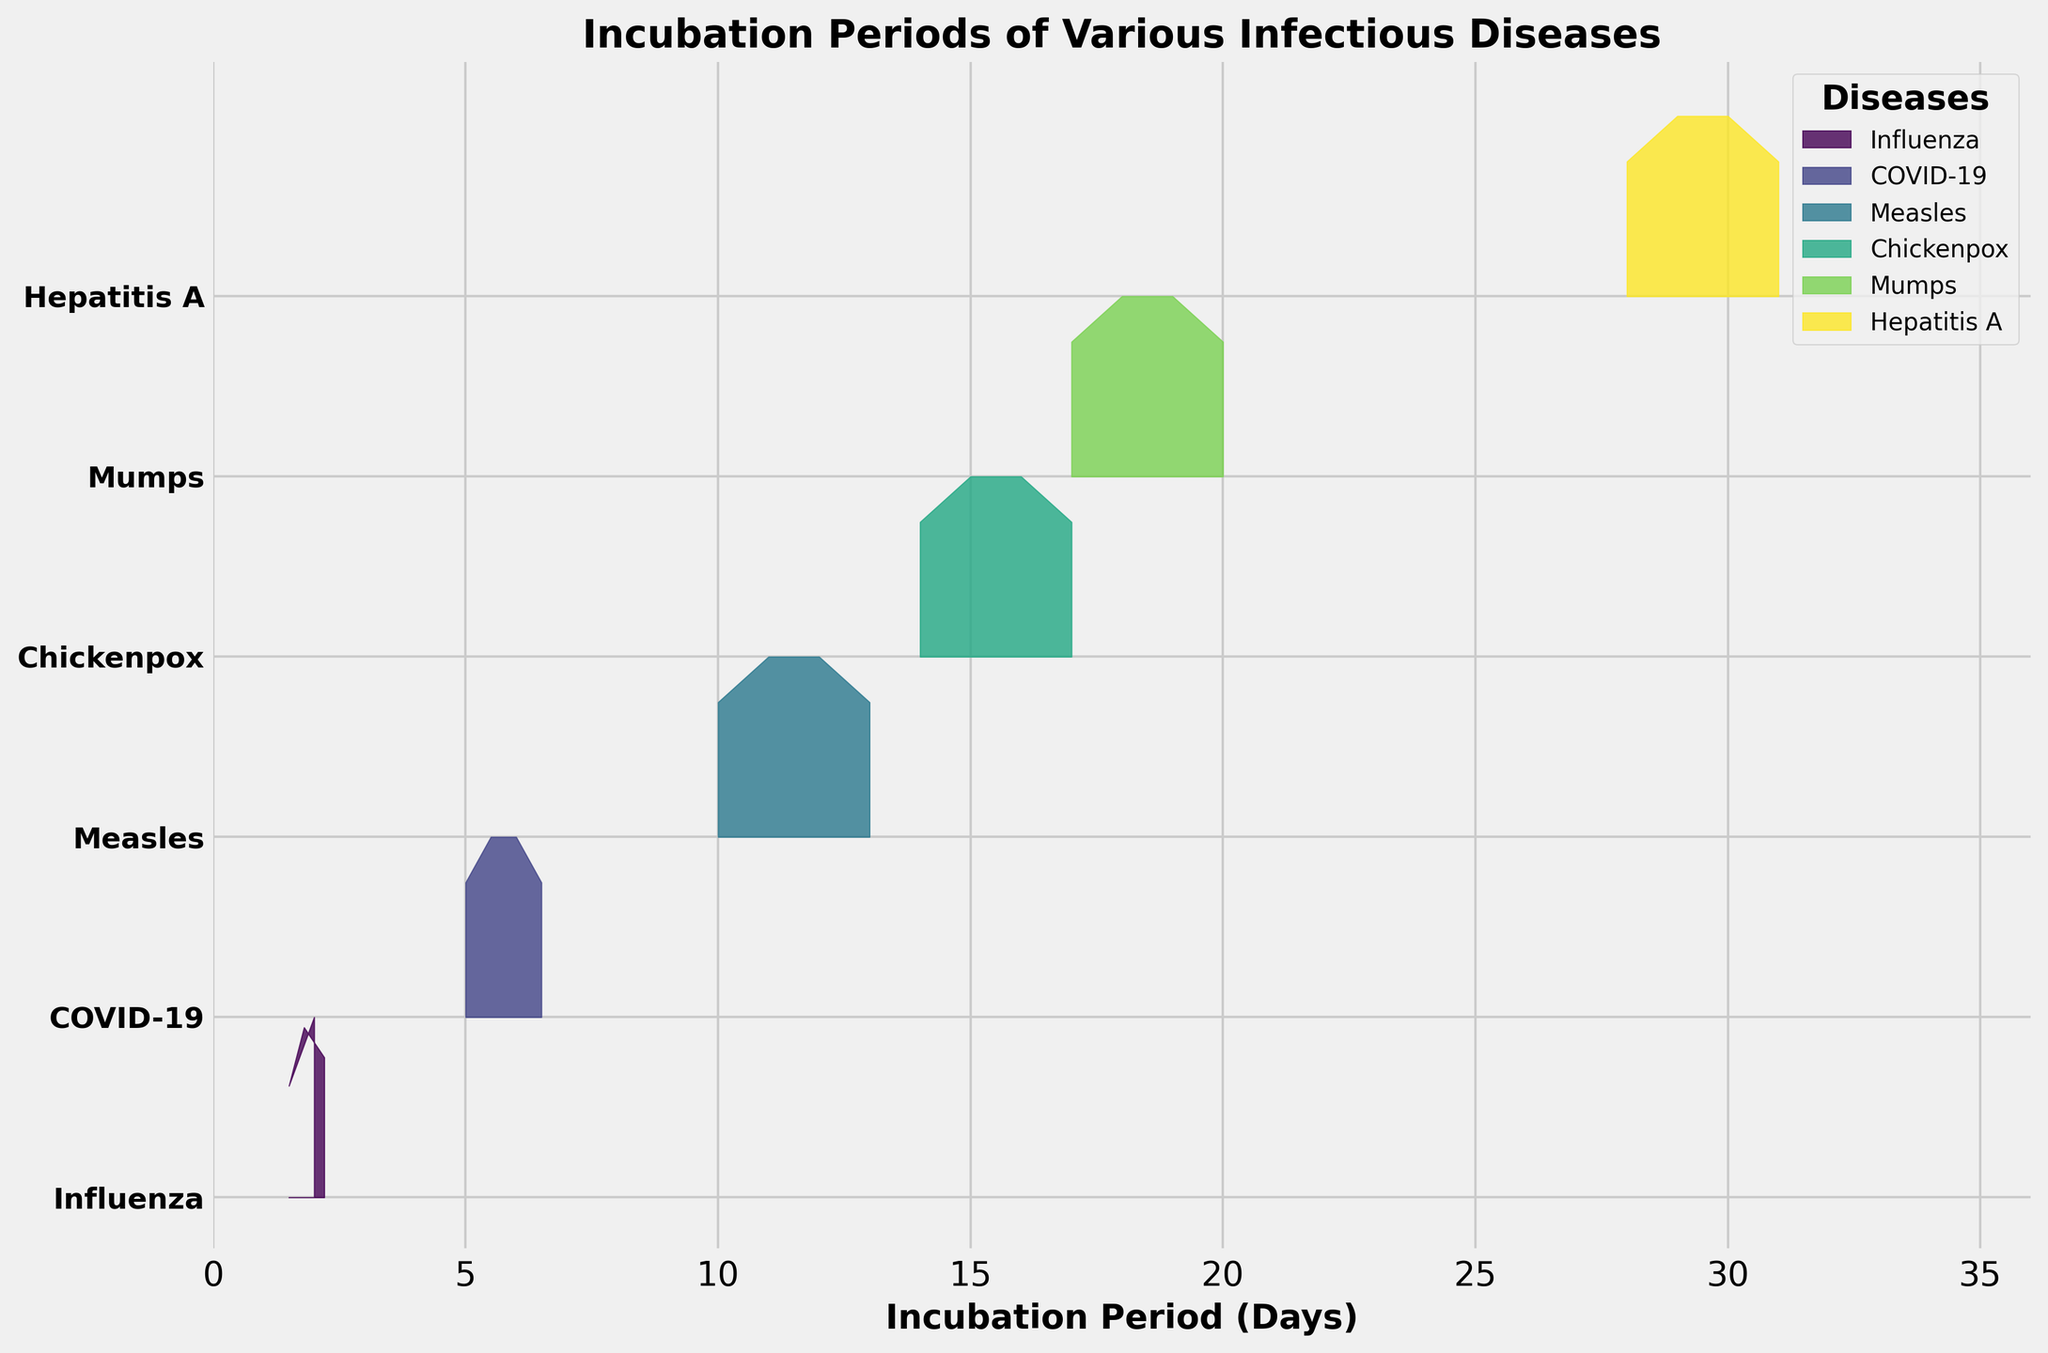What is the title of the figure? The title of the figure is usually positioned at the top center of the plot. In this case, it reads: "Incubation Periods of Various Infectious Diseases."
Answer: Incubation Periods of Various Infectious Diseases Which axis represents the incubation period in days? The axis representing the incubation period in days is labeled, and it's the horizontal axis (x-axis).
Answer: The horizontal axis What disease has the shortest average incubation period and what is that period? By examining the ridgeline plot, the disease with the shortest average incubation period will have its entire distribution shifted to the left on the x-axis. From the figure, Influenza is the disease with the shortest average incubation period. The value at the leftmost position of its ridgeline indicates about 1.5 to 2.2 days.
Answer: Influenza; 1.5-2.2 days Which disease shows the most significant spread of incubation periods across age groups? The spread of incubation periods can be determined by how wide the distribution is on the x-axis. By examining the figure, Hepatitis A has the widest spread of incubation periods, ranging roughly from 28 to 31 days.
Answer: Hepatitis A On average, which age group has a longer incubation period for Mumps, the 19-64 age group or the 65+ age group? Comparing the ridgeline shapes of the 19-64 and 65+ age groups for Mumps, we see that the peak for the 65+ age group is further to the right (towards longer incubation periods). Therefore, the 65+ age group has a longer incubation period on average.
Answer: 65+ age group What would be the average incubation period for COVID-19 across all age groups? To compute the average incubation period for COVID-19, sum the values for each age group and divide by the number of age groups: (5 + 5.5 + 6 + 6.5) / 4 = 23 / 4 = 5.75 days.
Answer: 5.75 days Are there any diseases with a consistent increase in incubation periods as the age groups increase? A disease with a consistent increase in incubation periods will show a clear trend where the curve shifts to the right for older age groups. For example, both Mumps and Hepatitis A show consistent increases across the age groups.
Answer: Mumps, Hepatitis A Which disease has the longest incubation period for the 0-5 age group and what is that period? By comparing the positions of the ridgelines for the 0-5 age group across all diseases, the rightmost peak corresponds to the disease with the longest incubation period. Hepatitis A, with an incubation period of 28 days, is the longest for the 0-5 age group.
Answer: Hepatitis A; 28 days How does the incubation period for Chickenpox compare between the 6-18 and 19-64 age groups? By examining the ridgeline plot, the incubation periods for Chickenpox in the 6-18 and 19-64 age groups can be compared. The 19-64 age group has a slightly longer incubation period, around 16 days compared to 15 days for the 6-18 age group.
Answer: The 19-64 age group has a longer incubation period Which disease has the steepest peak in its ridgeline plot, implying less variability in incubation period? The steepest peak in a ridgeline plot indicates a narrowly concentrated incubation period with low variability. From the plot, Influenza has the steepest peak, suggesting a relatively consistent incubation period across its age groups.
Answer: Influenza 